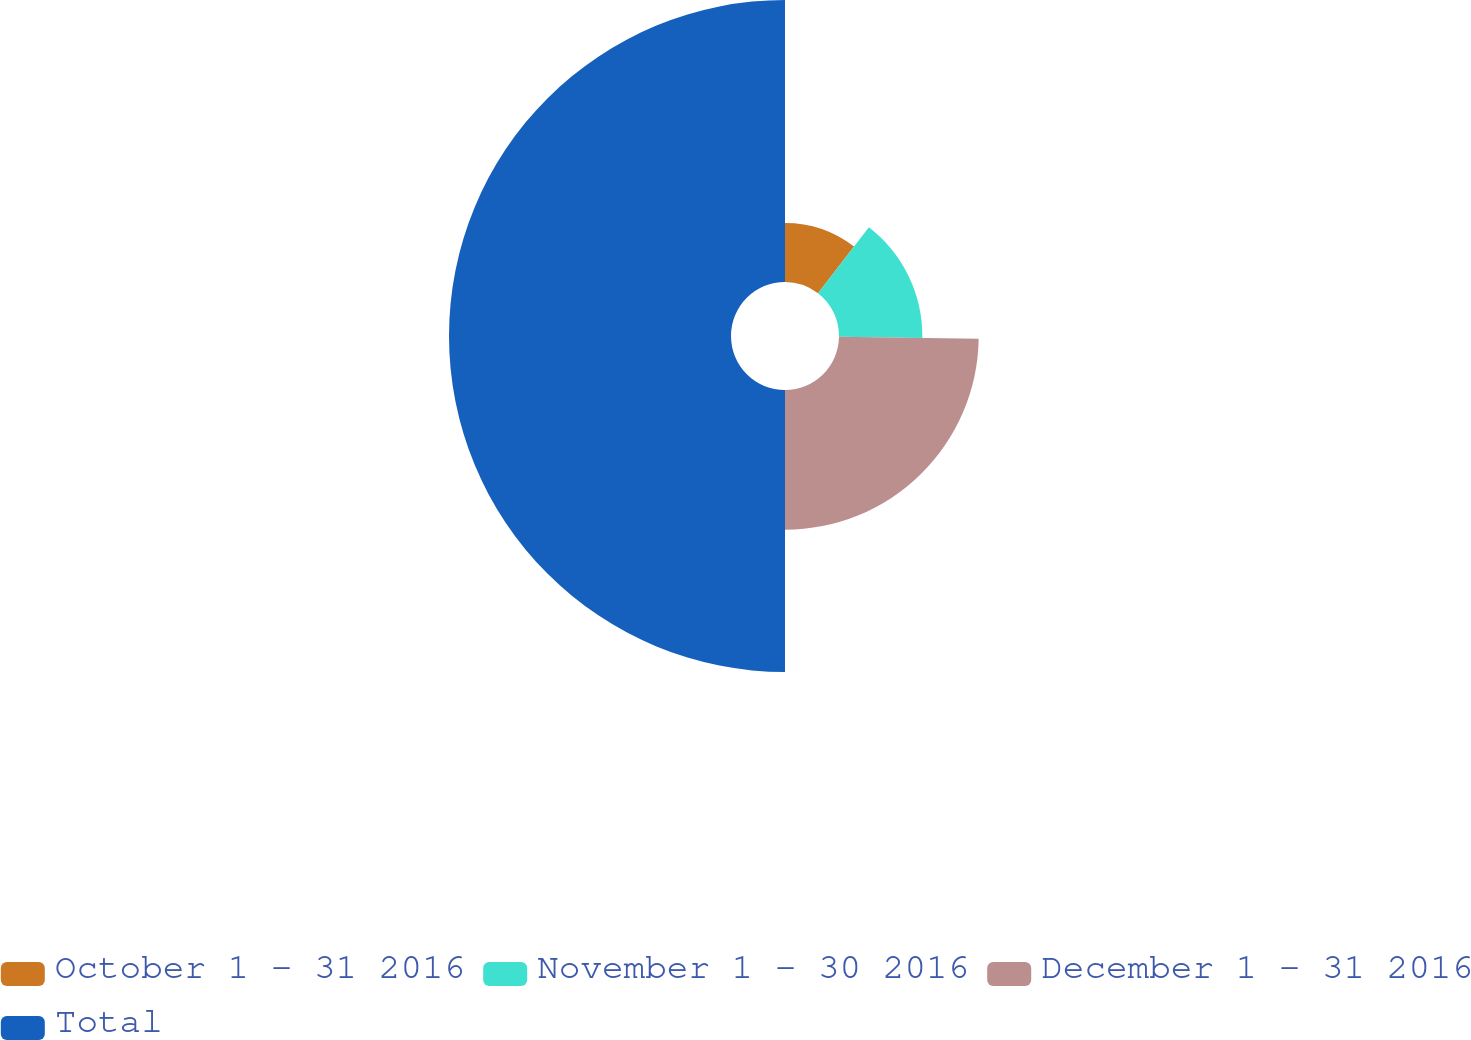Convert chart. <chart><loc_0><loc_0><loc_500><loc_500><pie_chart><fcel>October 1 - 31 2016<fcel>November 1 - 30 2016<fcel>December 1 - 31 2016<fcel>Total<nl><fcel>10.46%<fcel>14.77%<fcel>24.77%<fcel>50.0%<nl></chart> 